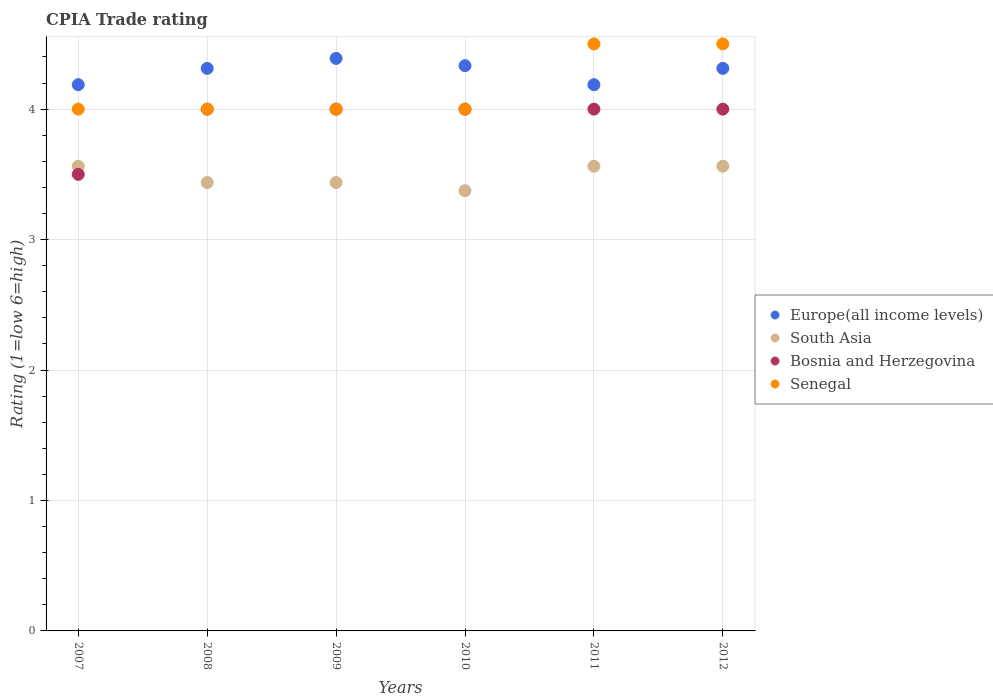Is the number of dotlines equal to the number of legend labels?
Keep it short and to the point. Yes. Across all years, what is the maximum CPIA rating in Bosnia and Herzegovina?
Offer a terse response. 4. Across all years, what is the minimum CPIA rating in Senegal?
Your answer should be very brief. 4. In which year was the CPIA rating in Senegal maximum?
Offer a very short reply. 2011. What is the total CPIA rating in Europe(all income levels) in the graph?
Provide a succinct answer. 25.72. What is the difference between the CPIA rating in Bosnia and Herzegovina in 2007 and that in 2009?
Your answer should be very brief. -0.5. What is the difference between the CPIA rating in Bosnia and Herzegovina in 2008 and the CPIA rating in Senegal in 2009?
Provide a short and direct response. 0. What is the average CPIA rating in South Asia per year?
Provide a short and direct response. 3.49. What is the ratio of the CPIA rating in Bosnia and Herzegovina in 2008 to that in 2009?
Keep it short and to the point. 1. What is the difference between the highest and the lowest CPIA rating in Europe(all income levels)?
Offer a very short reply. 0.2. In how many years, is the CPIA rating in South Asia greater than the average CPIA rating in South Asia taken over all years?
Give a very brief answer. 3. Is it the case that in every year, the sum of the CPIA rating in Europe(all income levels) and CPIA rating in Bosnia and Herzegovina  is greater than the sum of CPIA rating in Senegal and CPIA rating in South Asia?
Your response must be concise. No. Is the CPIA rating in Senegal strictly less than the CPIA rating in Bosnia and Herzegovina over the years?
Provide a succinct answer. No. How many dotlines are there?
Ensure brevity in your answer.  4. How many years are there in the graph?
Offer a terse response. 6. Are the values on the major ticks of Y-axis written in scientific E-notation?
Offer a terse response. No. Does the graph contain any zero values?
Ensure brevity in your answer.  No. Where does the legend appear in the graph?
Ensure brevity in your answer.  Center right. What is the title of the graph?
Provide a short and direct response. CPIA Trade rating. Does "World" appear as one of the legend labels in the graph?
Provide a succinct answer. No. What is the label or title of the X-axis?
Your answer should be compact. Years. What is the Rating (1=low 6=high) of Europe(all income levels) in 2007?
Provide a short and direct response. 4.19. What is the Rating (1=low 6=high) of South Asia in 2007?
Your response must be concise. 3.56. What is the Rating (1=low 6=high) of Bosnia and Herzegovina in 2007?
Your answer should be compact. 3.5. What is the Rating (1=low 6=high) of Europe(all income levels) in 2008?
Provide a short and direct response. 4.31. What is the Rating (1=low 6=high) in South Asia in 2008?
Your answer should be compact. 3.44. What is the Rating (1=low 6=high) in Europe(all income levels) in 2009?
Provide a succinct answer. 4.39. What is the Rating (1=low 6=high) in South Asia in 2009?
Offer a terse response. 3.44. What is the Rating (1=low 6=high) of Bosnia and Herzegovina in 2009?
Make the answer very short. 4. What is the Rating (1=low 6=high) in Senegal in 2009?
Your response must be concise. 4. What is the Rating (1=low 6=high) of Europe(all income levels) in 2010?
Provide a succinct answer. 4.33. What is the Rating (1=low 6=high) in South Asia in 2010?
Offer a very short reply. 3.38. What is the Rating (1=low 6=high) in Bosnia and Herzegovina in 2010?
Keep it short and to the point. 4. What is the Rating (1=low 6=high) of Europe(all income levels) in 2011?
Offer a very short reply. 4.19. What is the Rating (1=low 6=high) in South Asia in 2011?
Offer a very short reply. 3.56. What is the Rating (1=low 6=high) of Europe(all income levels) in 2012?
Ensure brevity in your answer.  4.31. What is the Rating (1=low 6=high) of South Asia in 2012?
Ensure brevity in your answer.  3.56. What is the Rating (1=low 6=high) of Bosnia and Herzegovina in 2012?
Your response must be concise. 4. Across all years, what is the maximum Rating (1=low 6=high) of Europe(all income levels)?
Your answer should be very brief. 4.39. Across all years, what is the maximum Rating (1=low 6=high) of South Asia?
Your answer should be very brief. 3.56. Across all years, what is the maximum Rating (1=low 6=high) of Bosnia and Herzegovina?
Provide a short and direct response. 4. Across all years, what is the minimum Rating (1=low 6=high) in Europe(all income levels)?
Provide a succinct answer. 4.19. Across all years, what is the minimum Rating (1=low 6=high) of South Asia?
Ensure brevity in your answer.  3.38. Across all years, what is the minimum Rating (1=low 6=high) of Bosnia and Herzegovina?
Your response must be concise. 3.5. What is the total Rating (1=low 6=high) of Europe(all income levels) in the graph?
Make the answer very short. 25.72. What is the total Rating (1=low 6=high) in South Asia in the graph?
Offer a very short reply. 20.94. What is the difference between the Rating (1=low 6=high) of Europe(all income levels) in 2007 and that in 2008?
Your answer should be compact. -0.12. What is the difference between the Rating (1=low 6=high) of South Asia in 2007 and that in 2008?
Your answer should be very brief. 0.12. What is the difference between the Rating (1=low 6=high) in Bosnia and Herzegovina in 2007 and that in 2008?
Keep it short and to the point. -0.5. What is the difference between the Rating (1=low 6=high) of Senegal in 2007 and that in 2008?
Offer a very short reply. 0. What is the difference between the Rating (1=low 6=high) in Europe(all income levels) in 2007 and that in 2009?
Your response must be concise. -0.2. What is the difference between the Rating (1=low 6=high) of Senegal in 2007 and that in 2009?
Ensure brevity in your answer.  0. What is the difference between the Rating (1=low 6=high) of Europe(all income levels) in 2007 and that in 2010?
Keep it short and to the point. -0.15. What is the difference between the Rating (1=low 6=high) in South Asia in 2007 and that in 2010?
Your answer should be compact. 0.19. What is the difference between the Rating (1=low 6=high) of Bosnia and Herzegovina in 2007 and that in 2010?
Offer a terse response. -0.5. What is the difference between the Rating (1=low 6=high) in Senegal in 2007 and that in 2010?
Ensure brevity in your answer.  0. What is the difference between the Rating (1=low 6=high) of Europe(all income levels) in 2007 and that in 2011?
Make the answer very short. 0. What is the difference between the Rating (1=low 6=high) in Bosnia and Herzegovina in 2007 and that in 2011?
Provide a succinct answer. -0.5. What is the difference between the Rating (1=low 6=high) of Senegal in 2007 and that in 2011?
Offer a terse response. -0.5. What is the difference between the Rating (1=low 6=high) in Europe(all income levels) in 2007 and that in 2012?
Keep it short and to the point. -0.12. What is the difference between the Rating (1=low 6=high) of Senegal in 2007 and that in 2012?
Offer a very short reply. -0.5. What is the difference between the Rating (1=low 6=high) in Europe(all income levels) in 2008 and that in 2009?
Give a very brief answer. -0.08. What is the difference between the Rating (1=low 6=high) of Senegal in 2008 and that in 2009?
Provide a short and direct response. 0. What is the difference between the Rating (1=low 6=high) of Europe(all income levels) in 2008 and that in 2010?
Offer a very short reply. -0.02. What is the difference between the Rating (1=low 6=high) of South Asia in 2008 and that in 2010?
Keep it short and to the point. 0.06. What is the difference between the Rating (1=low 6=high) of Bosnia and Herzegovina in 2008 and that in 2010?
Keep it short and to the point. 0. What is the difference between the Rating (1=low 6=high) of South Asia in 2008 and that in 2011?
Provide a short and direct response. -0.12. What is the difference between the Rating (1=low 6=high) in Senegal in 2008 and that in 2011?
Your response must be concise. -0.5. What is the difference between the Rating (1=low 6=high) of Europe(all income levels) in 2008 and that in 2012?
Offer a terse response. 0. What is the difference between the Rating (1=low 6=high) of South Asia in 2008 and that in 2012?
Make the answer very short. -0.12. What is the difference between the Rating (1=low 6=high) in Bosnia and Herzegovina in 2008 and that in 2012?
Your answer should be compact. 0. What is the difference between the Rating (1=low 6=high) in Senegal in 2008 and that in 2012?
Offer a terse response. -0.5. What is the difference between the Rating (1=low 6=high) of Europe(all income levels) in 2009 and that in 2010?
Offer a very short reply. 0.06. What is the difference between the Rating (1=low 6=high) in South Asia in 2009 and that in 2010?
Give a very brief answer. 0.06. What is the difference between the Rating (1=low 6=high) of Bosnia and Herzegovina in 2009 and that in 2010?
Give a very brief answer. 0. What is the difference between the Rating (1=low 6=high) of Senegal in 2009 and that in 2010?
Your response must be concise. 0. What is the difference between the Rating (1=low 6=high) in Europe(all income levels) in 2009 and that in 2011?
Offer a terse response. 0.2. What is the difference between the Rating (1=low 6=high) in South Asia in 2009 and that in 2011?
Make the answer very short. -0.12. What is the difference between the Rating (1=low 6=high) of Europe(all income levels) in 2009 and that in 2012?
Make the answer very short. 0.08. What is the difference between the Rating (1=low 6=high) of South Asia in 2009 and that in 2012?
Your answer should be compact. -0.12. What is the difference between the Rating (1=low 6=high) in Bosnia and Herzegovina in 2009 and that in 2012?
Offer a terse response. 0. What is the difference between the Rating (1=low 6=high) of Europe(all income levels) in 2010 and that in 2011?
Keep it short and to the point. 0.15. What is the difference between the Rating (1=low 6=high) in South Asia in 2010 and that in 2011?
Your answer should be compact. -0.19. What is the difference between the Rating (1=low 6=high) in Senegal in 2010 and that in 2011?
Offer a very short reply. -0.5. What is the difference between the Rating (1=low 6=high) of Europe(all income levels) in 2010 and that in 2012?
Provide a short and direct response. 0.02. What is the difference between the Rating (1=low 6=high) of South Asia in 2010 and that in 2012?
Ensure brevity in your answer.  -0.19. What is the difference between the Rating (1=low 6=high) of Europe(all income levels) in 2011 and that in 2012?
Keep it short and to the point. -0.12. What is the difference between the Rating (1=low 6=high) in Bosnia and Herzegovina in 2011 and that in 2012?
Make the answer very short. 0. What is the difference between the Rating (1=low 6=high) of Europe(all income levels) in 2007 and the Rating (1=low 6=high) of Bosnia and Herzegovina in 2008?
Make the answer very short. 0.19. What is the difference between the Rating (1=low 6=high) in Europe(all income levels) in 2007 and the Rating (1=low 6=high) in Senegal in 2008?
Provide a short and direct response. 0.19. What is the difference between the Rating (1=low 6=high) in South Asia in 2007 and the Rating (1=low 6=high) in Bosnia and Herzegovina in 2008?
Provide a succinct answer. -0.44. What is the difference between the Rating (1=low 6=high) in South Asia in 2007 and the Rating (1=low 6=high) in Senegal in 2008?
Your answer should be very brief. -0.44. What is the difference between the Rating (1=low 6=high) of Bosnia and Herzegovina in 2007 and the Rating (1=low 6=high) of Senegal in 2008?
Offer a very short reply. -0.5. What is the difference between the Rating (1=low 6=high) of Europe(all income levels) in 2007 and the Rating (1=low 6=high) of Bosnia and Herzegovina in 2009?
Ensure brevity in your answer.  0.19. What is the difference between the Rating (1=low 6=high) of Europe(all income levels) in 2007 and the Rating (1=low 6=high) of Senegal in 2009?
Your answer should be compact. 0.19. What is the difference between the Rating (1=low 6=high) of South Asia in 2007 and the Rating (1=low 6=high) of Bosnia and Herzegovina in 2009?
Your answer should be compact. -0.44. What is the difference between the Rating (1=low 6=high) of South Asia in 2007 and the Rating (1=low 6=high) of Senegal in 2009?
Offer a very short reply. -0.44. What is the difference between the Rating (1=low 6=high) of Europe(all income levels) in 2007 and the Rating (1=low 6=high) of South Asia in 2010?
Your response must be concise. 0.81. What is the difference between the Rating (1=low 6=high) of Europe(all income levels) in 2007 and the Rating (1=low 6=high) of Bosnia and Herzegovina in 2010?
Make the answer very short. 0.19. What is the difference between the Rating (1=low 6=high) of Europe(all income levels) in 2007 and the Rating (1=low 6=high) of Senegal in 2010?
Offer a terse response. 0.19. What is the difference between the Rating (1=low 6=high) in South Asia in 2007 and the Rating (1=low 6=high) in Bosnia and Herzegovina in 2010?
Give a very brief answer. -0.44. What is the difference between the Rating (1=low 6=high) of South Asia in 2007 and the Rating (1=low 6=high) of Senegal in 2010?
Your response must be concise. -0.44. What is the difference between the Rating (1=low 6=high) in Europe(all income levels) in 2007 and the Rating (1=low 6=high) in Bosnia and Herzegovina in 2011?
Your answer should be very brief. 0.19. What is the difference between the Rating (1=low 6=high) of Europe(all income levels) in 2007 and the Rating (1=low 6=high) of Senegal in 2011?
Your answer should be very brief. -0.31. What is the difference between the Rating (1=low 6=high) of South Asia in 2007 and the Rating (1=low 6=high) of Bosnia and Herzegovina in 2011?
Your answer should be compact. -0.44. What is the difference between the Rating (1=low 6=high) in South Asia in 2007 and the Rating (1=low 6=high) in Senegal in 2011?
Your response must be concise. -0.94. What is the difference between the Rating (1=low 6=high) of Europe(all income levels) in 2007 and the Rating (1=low 6=high) of Bosnia and Herzegovina in 2012?
Provide a succinct answer. 0.19. What is the difference between the Rating (1=low 6=high) of Europe(all income levels) in 2007 and the Rating (1=low 6=high) of Senegal in 2012?
Keep it short and to the point. -0.31. What is the difference between the Rating (1=low 6=high) of South Asia in 2007 and the Rating (1=low 6=high) of Bosnia and Herzegovina in 2012?
Provide a succinct answer. -0.44. What is the difference between the Rating (1=low 6=high) in South Asia in 2007 and the Rating (1=low 6=high) in Senegal in 2012?
Ensure brevity in your answer.  -0.94. What is the difference between the Rating (1=low 6=high) in Europe(all income levels) in 2008 and the Rating (1=low 6=high) in Bosnia and Herzegovina in 2009?
Your response must be concise. 0.31. What is the difference between the Rating (1=low 6=high) in Europe(all income levels) in 2008 and the Rating (1=low 6=high) in Senegal in 2009?
Provide a succinct answer. 0.31. What is the difference between the Rating (1=low 6=high) in South Asia in 2008 and the Rating (1=low 6=high) in Bosnia and Herzegovina in 2009?
Offer a terse response. -0.56. What is the difference between the Rating (1=low 6=high) in South Asia in 2008 and the Rating (1=low 6=high) in Senegal in 2009?
Offer a very short reply. -0.56. What is the difference between the Rating (1=low 6=high) of Europe(all income levels) in 2008 and the Rating (1=low 6=high) of Bosnia and Herzegovina in 2010?
Provide a short and direct response. 0.31. What is the difference between the Rating (1=low 6=high) in Europe(all income levels) in 2008 and the Rating (1=low 6=high) in Senegal in 2010?
Offer a very short reply. 0.31. What is the difference between the Rating (1=low 6=high) in South Asia in 2008 and the Rating (1=low 6=high) in Bosnia and Herzegovina in 2010?
Make the answer very short. -0.56. What is the difference between the Rating (1=low 6=high) in South Asia in 2008 and the Rating (1=low 6=high) in Senegal in 2010?
Your response must be concise. -0.56. What is the difference between the Rating (1=low 6=high) of Europe(all income levels) in 2008 and the Rating (1=low 6=high) of Bosnia and Herzegovina in 2011?
Give a very brief answer. 0.31. What is the difference between the Rating (1=low 6=high) of Europe(all income levels) in 2008 and the Rating (1=low 6=high) of Senegal in 2011?
Provide a succinct answer. -0.19. What is the difference between the Rating (1=low 6=high) in South Asia in 2008 and the Rating (1=low 6=high) in Bosnia and Herzegovina in 2011?
Your answer should be compact. -0.56. What is the difference between the Rating (1=low 6=high) in South Asia in 2008 and the Rating (1=low 6=high) in Senegal in 2011?
Your answer should be compact. -1.06. What is the difference between the Rating (1=low 6=high) of Europe(all income levels) in 2008 and the Rating (1=low 6=high) of Bosnia and Herzegovina in 2012?
Keep it short and to the point. 0.31. What is the difference between the Rating (1=low 6=high) in Europe(all income levels) in 2008 and the Rating (1=low 6=high) in Senegal in 2012?
Provide a succinct answer. -0.19. What is the difference between the Rating (1=low 6=high) of South Asia in 2008 and the Rating (1=low 6=high) of Bosnia and Herzegovina in 2012?
Provide a short and direct response. -0.56. What is the difference between the Rating (1=low 6=high) of South Asia in 2008 and the Rating (1=low 6=high) of Senegal in 2012?
Make the answer very short. -1.06. What is the difference between the Rating (1=low 6=high) of Europe(all income levels) in 2009 and the Rating (1=low 6=high) of South Asia in 2010?
Provide a short and direct response. 1.01. What is the difference between the Rating (1=low 6=high) of Europe(all income levels) in 2009 and the Rating (1=low 6=high) of Bosnia and Herzegovina in 2010?
Offer a terse response. 0.39. What is the difference between the Rating (1=low 6=high) of Europe(all income levels) in 2009 and the Rating (1=low 6=high) of Senegal in 2010?
Keep it short and to the point. 0.39. What is the difference between the Rating (1=low 6=high) of South Asia in 2009 and the Rating (1=low 6=high) of Bosnia and Herzegovina in 2010?
Make the answer very short. -0.56. What is the difference between the Rating (1=low 6=high) of South Asia in 2009 and the Rating (1=low 6=high) of Senegal in 2010?
Provide a short and direct response. -0.56. What is the difference between the Rating (1=low 6=high) in Bosnia and Herzegovina in 2009 and the Rating (1=low 6=high) in Senegal in 2010?
Offer a very short reply. 0. What is the difference between the Rating (1=low 6=high) of Europe(all income levels) in 2009 and the Rating (1=low 6=high) of South Asia in 2011?
Offer a very short reply. 0.83. What is the difference between the Rating (1=low 6=high) of Europe(all income levels) in 2009 and the Rating (1=low 6=high) of Bosnia and Herzegovina in 2011?
Make the answer very short. 0.39. What is the difference between the Rating (1=low 6=high) in Europe(all income levels) in 2009 and the Rating (1=low 6=high) in Senegal in 2011?
Your response must be concise. -0.11. What is the difference between the Rating (1=low 6=high) of South Asia in 2009 and the Rating (1=low 6=high) of Bosnia and Herzegovina in 2011?
Offer a terse response. -0.56. What is the difference between the Rating (1=low 6=high) of South Asia in 2009 and the Rating (1=low 6=high) of Senegal in 2011?
Your answer should be very brief. -1.06. What is the difference between the Rating (1=low 6=high) in Bosnia and Herzegovina in 2009 and the Rating (1=low 6=high) in Senegal in 2011?
Keep it short and to the point. -0.5. What is the difference between the Rating (1=low 6=high) in Europe(all income levels) in 2009 and the Rating (1=low 6=high) in South Asia in 2012?
Provide a short and direct response. 0.83. What is the difference between the Rating (1=low 6=high) in Europe(all income levels) in 2009 and the Rating (1=low 6=high) in Bosnia and Herzegovina in 2012?
Your response must be concise. 0.39. What is the difference between the Rating (1=low 6=high) in Europe(all income levels) in 2009 and the Rating (1=low 6=high) in Senegal in 2012?
Provide a succinct answer. -0.11. What is the difference between the Rating (1=low 6=high) of South Asia in 2009 and the Rating (1=low 6=high) of Bosnia and Herzegovina in 2012?
Your answer should be very brief. -0.56. What is the difference between the Rating (1=low 6=high) in South Asia in 2009 and the Rating (1=low 6=high) in Senegal in 2012?
Your response must be concise. -1.06. What is the difference between the Rating (1=low 6=high) in Europe(all income levels) in 2010 and the Rating (1=low 6=high) in South Asia in 2011?
Make the answer very short. 0.77. What is the difference between the Rating (1=low 6=high) of South Asia in 2010 and the Rating (1=low 6=high) of Bosnia and Herzegovina in 2011?
Offer a very short reply. -0.62. What is the difference between the Rating (1=low 6=high) of South Asia in 2010 and the Rating (1=low 6=high) of Senegal in 2011?
Your response must be concise. -1.12. What is the difference between the Rating (1=low 6=high) of Bosnia and Herzegovina in 2010 and the Rating (1=low 6=high) of Senegal in 2011?
Give a very brief answer. -0.5. What is the difference between the Rating (1=low 6=high) in Europe(all income levels) in 2010 and the Rating (1=low 6=high) in South Asia in 2012?
Offer a very short reply. 0.77. What is the difference between the Rating (1=low 6=high) in South Asia in 2010 and the Rating (1=low 6=high) in Bosnia and Herzegovina in 2012?
Give a very brief answer. -0.62. What is the difference between the Rating (1=low 6=high) in South Asia in 2010 and the Rating (1=low 6=high) in Senegal in 2012?
Your response must be concise. -1.12. What is the difference between the Rating (1=low 6=high) in Europe(all income levels) in 2011 and the Rating (1=low 6=high) in Bosnia and Herzegovina in 2012?
Offer a very short reply. 0.19. What is the difference between the Rating (1=low 6=high) in Europe(all income levels) in 2011 and the Rating (1=low 6=high) in Senegal in 2012?
Give a very brief answer. -0.31. What is the difference between the Rating (1=low 6=high) in South Asia in 2011 and the Rating (1=low 6=high) in Bosnia and Herzegovina in 2012?
Offer a terse response. -0.44. What is the difference between the Rating (1=low 6=high) in South Asia in 2011 and the Rating (1=low 6=high) in Senegal in 2012?
Your answer should be compact. -0.94. What is the difference between the Rating (1=low 6=high) of Bosnia and Herzegovina in 2011 and the Rating (1=low 6=high) of Senegal in 2012?
Your answer should be compact. -0.5. What is the average Rating (1=low 6=high) in Europe(all income levels) per year?
Offer a terse response. 4.29. What is the average Rating (1=low 6=high) of South Asia per year?
Your answer should be very brief. 3.49. What is the average Rating (1=low 6=high) of Bosnia and Herzegovina per year?
Your response must be concise. 3.92. What is the average Rating (1=low 6=high) of Senegal per year?
Keep it short and to the point. 4.17. In the year 2007, what is the difference between the Rating (1=low 6=high) of Europe(all income levels) and Rating (1=low 6=high) of South Asia?
Offer a very short reply. 0.62. In the year 2007, what is the difference between the Rating (1=low 6=high) in Europe(all income levels) and Rating (1=low 6=high) in Bosnia and Herzegovina?
Make the answer very short. 0.69. In the year 2007, what is the difference between the Rating (1=low 6=high) in Europe(all income levels) and Rating (1=low 6=high) in Senegal?
Offer a terse response. 0.19. In the year 2007, what is the difference between the Rating (1=low 6=high) of South Asia and Rating (1=low 6=high) of Bosnia and Herzegovina?
Your response must be concise. 0.06. In the year 2007, what is the difference between the Rating (1=low 6=high) of South Asia and Rating (1=low 6=high) of Senegal?
Provide a short and direct response. -0.44. In the year 2008, what is the difference between the Rating (1=low 6=high) in Europe(all income levels) and Rating (1=low 6=high) in South Asia?
Provide a short and direct response. 0.88. In the year 2008, what is the difference between the Rating (1=low 6=high) in Europe(all income levels) and Rating (1=low 6=high) in Bosnia and Herzegovina?
Your answer should be compact. 0.31. In the year 2008, what is the difference between the Rating (1=low 6=high) of Europe(all income levels) and Rating (1=low 6=high) of Senegal?
Give a very brief answer. 0.31. In the year 2008, what is the difference between the Rating (1=low 6=high) of South Asia and Rating (1=low 6=high) of Bosnia and Herzegovina?
Offer a terse response. -0.56. In the year 2008, what is the difference between the Rating (1=low 6=high) in South Asia and Rating (1=low 6=high) in Senegal?
Your answer should be very brief. -0.56. In the year 2008, what is the difference between the Rating (1=low 6=high) in Bosnia and Herzegovina and Rating (1=low 6=high) in Senegal?
Your answer should be very brief. 0. In the year 2009, what is the difference between the Rating (1=low 6=high) in Europe(all income levels) and Rating (1=low 6=high) in South Asia?
Your answer should be compact. 0.95. In the year 2009, what is the difference between the Rating (1=low 6=high) of Europe(all income levels) and Rating (1=low 6=high) of Bosnia and Herzegovina?
Make the answer very short. 0.39. In the year 2009, what is the difference between the Rating (1=low 6=high) of Europe(all income levels) and Rating (1=low 6=high) of Senegal?
Your answer should be very brief. 0.39. In the year 2009, what is the difference between the Rating (1=low 6=high) in South Asia and Rating (1=low 6=high) in Bosnia and Herzegovina?
Provide a succinct answer. -0.56. In the year 2009, what is the difference between the Rating (1=low 6=high) of South Asia and Rating (1=low 6=high) of Senegal?
Your answer should be compact. -0.56. In the year 2010, what is the difference between the Rating (1=low 6=high) of Europe(all income levels) and Rating (1=low 6=high) of Bosnia and Herzegovina?
Make the answer very short. 0.33. In the year 2010, what is the difference between the Rating (1=low 6=high) of South Asia and Rating (1=low 6=high) of Bosnia and Herzegovina?
Offer a terse response. -0.62. In the year 2010, what is the difference between the Rating (1=low 6=high) of South Asia and Rating (1=low 6=high) of Senegal?
Provide a succinct answer. -0.62. In the year 2011, what is the difference between the Rating (1=low 6=high) in Europe(all income levels) and Rating (1=low 6=high) in Bosnia and Herzegovina?
Give a very brief answer. 0.19. In the year 2011, what is the difference between the Rating (1=low 6=high) in Europe(all income levels) and Rating (1=low 6=high) in Senegal?
Give a very brief answer. -0.31. In the year 2011, what is the difference between the Rating (1=low 6=high) in South Asia and Rating (1=low 6=high) in Bosnia and Herzegovina?
Your answer should be very brief. -0.44. In the year 2011, what is the difference between the Rating (1=low 6=high) in South Asia and Rating (1=low 6=high) in Senegal?
Provide a short and direct response. -0.94. In the year 2011, what is the difference between the Rating (1=low 6=high) of Bosnia and Herzegovina and Rating (1=low 6=high) of Senegal?
Provide a short and direct response. -0.5. In the year 2012, what is the difference between the Rating (1=low 6=high) in Europe(all income levels) and Rating (1=low 6=high) in Bosnia and Herzegovina?
Make the answer very short. 0.31. In the year 2012, what is the difference between the Rating (1=low 6=high) in Europe(all income levels) and Rating (1=low 6=high) in Senegal?
Make the answer very short. -0.19. In the year 2012, what is the difference between the Rating (1=low 6=high) of South Asia and Rating (1=low 6=high) of Bosnia and Herzegovina?
Give a very brief answer. -0.44. In the year 2012, what is the difference between the Rating (1=low 6=high) of South Asia and Rating (1=low 6=high) of Senegal?
Offer a very short reply. -0.94. In the year 2012, what is the difference between the Rating (1=low 6=high) in Bosnia and Herzegovina and Rating (1=low 6=high) in Senegal?
Your response must be concise. -0.5. What is the ratio of the Rating (1=low 6=high) in Europe(all income levels) in 2007 to that in 2008?
Offer a very short reply. 0.97. What is the ratio of the Rating (1=low 6=high) of South Asia in 2007 to that in 2008?
Your answer should be compact. 1.04. What is the ratio of the Rating (1=low 6=high) of Bosnia and Herzegovina in 2007 to that in 2008?
Keep it short and to the point. 0.88. What is the ratio of the Rating (1=low 6=high) in Europe(all income levels) in 2007 to that in 2009?
Offer a terse response. 0.95. What is the ratio of the Rating (1=low 6=high) of South Asia in 2007 to that in 2009?
Ensure brevity in your answer.  1.04. What is the ratio of the Rating (1=low 6=high) of Bosnia and Herzegovina in 2007 to that in 2009?
Offer a terse response. 0.88. What is the ratio of the Rating (1=low 6=high) in Europe(all income levels) in 2007 to that in 2010?
Provide a succinct answer. 0.97. What is the ratio of the Rating (1=low 6=high) of South Asia in 2007 to that in 2010?
Your answer should be compact. 1.06. What is the ratio of the Rating (1=low 6=high) of Senegal in 2007 to that in 2010?
Offer a very short reply. 1. What is the ratio of the Rating (1=low 6=high) in Europe(all income levels) in 2007 to that in 2011?
Give a very brief answer. 1. What is the ratio of the Rating (1=low 6=high) of Europe(all income levels) in 2007 to that in 2012?
Provide a short and direct response. 0.97. What is the ratio of the Rating (1=low 6=high) in South Asia in 2007 to that in 2012?
Provide a short and direct response. 1. What is the ratio of the Rating (1=low 6=high) of Bosnia and Herzegovina in 2007 to that in 2012?
Your response must be concise. 0.88. What is the ratio of the Rating (1=low 6=high) in Europe(all income levels) in 2008 to that in 2009?
Provide a succinct answer. 0.98. What is the ratio of the Rating (1=low 6=high) of South Asia in 2008 to that in 2009?
Provide a short and direct response. 1. What is the ratio of the Rating (1=low 6=high) of Bosnia and Herzegovina in 2008 to that in 2009?
Offer a terse response. 1. What is the ratio of the Rating (1=low 6=high) of Senegal in 2008 to that in 2009?
Provide a short and direct response. 1. What is the ratio of the Rating (1=low 6=high) in South Asia in 2008 to that in 2010?
Ensure brevity in your answer.  1.02. What is the ratio of the Rating (1=low 6=high) in Europe(all income levels) in 2008 to that in 2011?
Offer a very short reply. 1.03. What is the ratio of the Rating (1=low 6=high) in South Asia in 2008 to that in 2011?
Give a very brief answer. 0.96. What is the ratio of the Rating (1=low 6=high) of Senegal in 2008 to that in 2011?
Your response must be concise. 0.89. What is the ratio of the Rating (1=low 6=high) in South Asia in 2008 to that in 2012?
Ensure brevity in your answer.  0.96. What is the ratio of the Rating (1=low 6=high) in Senegal in 2008 to that in 2012?
Provide a succinct answer. 0.89. What is the ratio of the Rating (1=low 6=high) of Europe(all income levels) in 2009 to that in 2010?
Provide a short and direct response. 1.01. What is the ratio of the Rating (1=low 6=high) of South Asia in 2009 to that in 2010?
Give a very brief answer. 1.02. What is the ratio of the Rating (1=low 6=high) in Bosnia and Herzegovina in 2009 to that in 2010?
Make the answer very short. 1. What is the ratio of the Rating (1=low 6=high) of Europe(all income levels) in 2009 to that in 2011?
Offer a very short reply. 1.05. What is the ratio of the Rating (1=low 6=high) in South Asia in 2009 to that in 2011?
Give a very brief answer. 0.96. What is the ratio of the Rating (1=low 6=high) in Europe(all income levels) in 2009 to that in 2012?
Ensure brevity in your answer.  1.02. What is the ratio of the Rating (1=low 6=high) in South Asia in 2009 to that in 2012?
Provide a short and direct response. 0.96. What is the ratio of the Rating (1=low 6=high) in Europe(all income levels) in 2010 to that in 2011?
Give a very brief answer. 1.03. What is the ratio of the Rating (1=low 6=high) in Bosnia and Herzegovina in 2010 to that in 2011?
Keep it short and to the point. 1. What is the ratio of the Rating (1=low 6=high) in Europe(all income levels) in 2010 to that in 2012?
Your answer should be compact. 1. What is the ratio of the Rating (1=low 6=high) in Bosnia and Herzegovina in 2010 to that in 2012?
Make the answer very short. 1. What is the ratio of the Rating (1=low 6=high) of Europe(all income levels) in 2011 to that in 2012?
Your response must be concise. 0.97. What is the ratio of the Rating (1=low 6=high) of Bosnia and Herzegovina in 2011 to that in 2012?
Your response must be concise. 1. What is the ratio of the Rating (1=low 6=high) of Senegal in 2011 to that in 2012?
Your response must be concise. 1. What is the difference between the highest and the second highest Rating (1=low 6=high) in Europe(all income levels)?
Your answer should be very brief. 0.06. What is the difference between the highest and the second highest Rating (1=low 6=high) of South Asia?
Your answer should be very brief. 0. What is the difference between the highest and the second highest Rating (1=low 6=high) in Bosnia and Herzegovina?
Ensure brevity in your answer.  0. What is the difference between the highest and the lowest Rating (1=low 6=high) of Europe(all income levels)?
Your response must be concise. 0.2. What is the difference between the highest and the lowest Rating (1=low 6=high) in South Asia?
Your answer should be compact. 0.19. What is the difference between the highest and the lowest Rating (1=low 6=high) in Senegal?
Your answer should be compact. 0.5. 